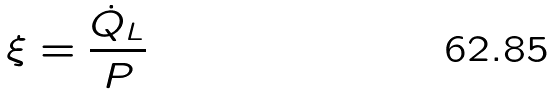<formula> <loc_0><loc_0><loc_500><loc_500>\xi = \frac { \dot { Q } _ { L } } { P }</formula> 